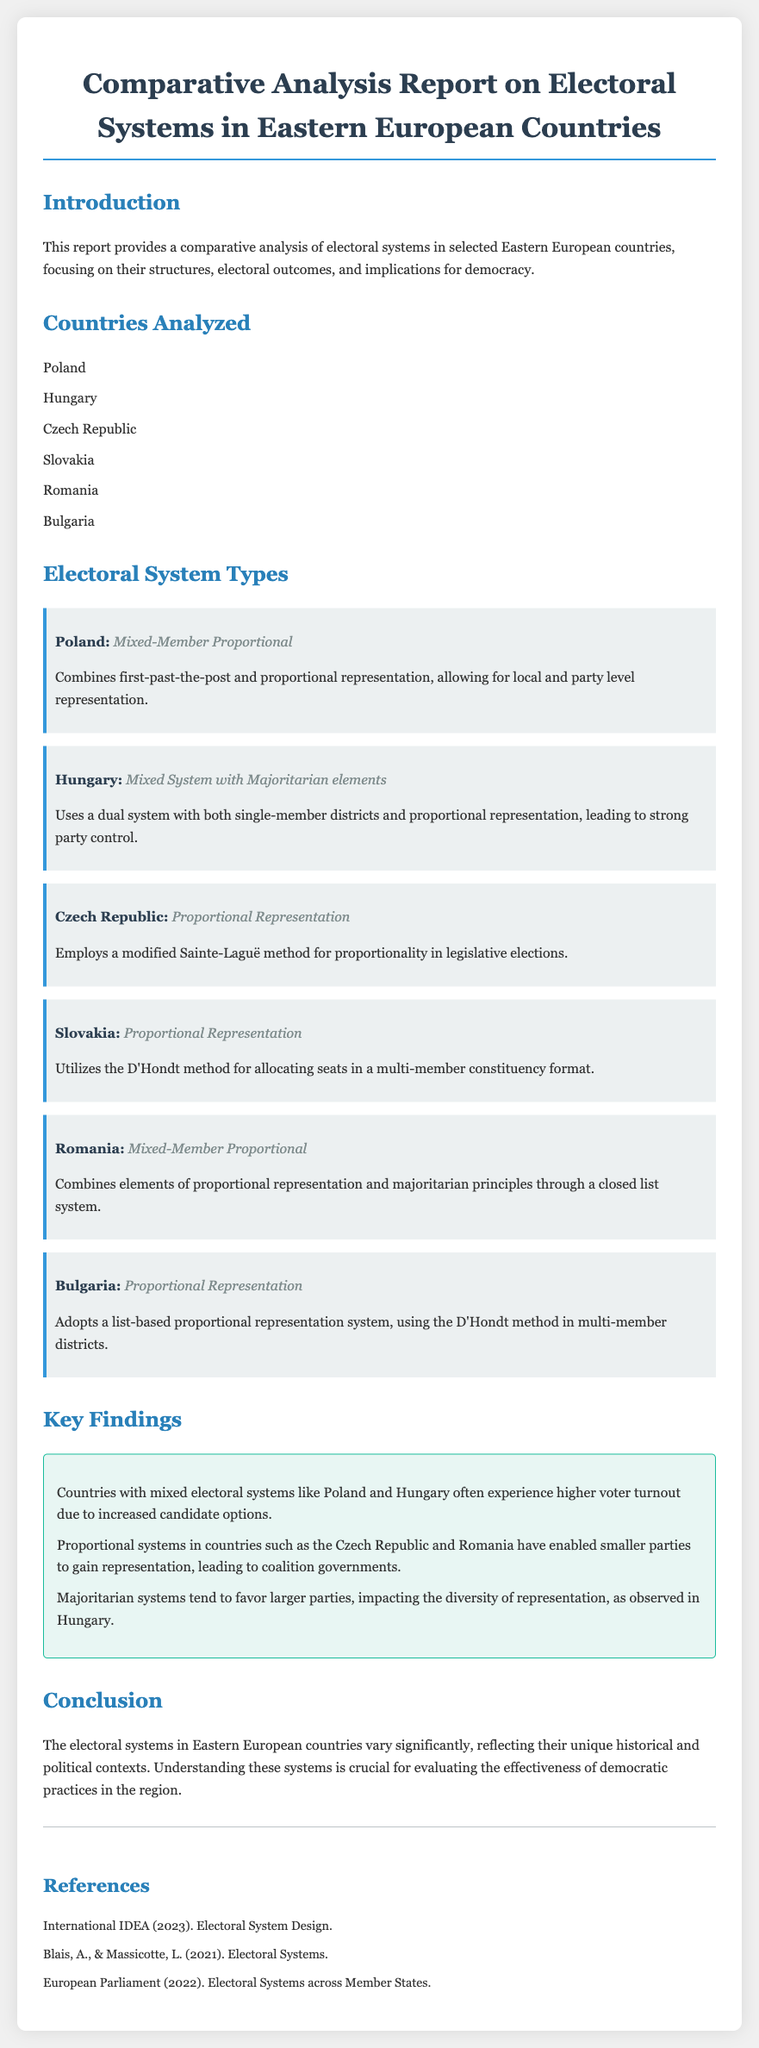What are the countries analyzed? The document lists the countries analyzed in the report under the section "Countries Analyzed."
Answer: Poland, Hungary, Czech Republic, Slovakia, Romania, Bulgaria What electoral system does Poland use? The document specifies the electoral system used in Poland in the "Electoral System Types" section.
Answer: Mixed-Member Proportional What method is used in the Czech Republic for proportional representation? The document describes the method used for proportional representation in the Czech Republic.
Answer: Modified Sainte-Laguë method Which country has a mixed system with majoritarian elements? The report identifies the country with this specific electoral system type in the "Electoral System Types" section.
Answer: Hungary What is one key finding related to mixed electoral systems? The document provides key findings about mixed electoral systems under the "Key Findings" section.
Answer: Higher voter turnout due to increased candidate options Which electoral system is used in Bulgaria? The document notes the type of electoral system Bulgaria employs in the "Electoral System Types" section.
Answer: Proportional Representation What kind of representation do smaller parties gain in proportional systems? The document mentions the impact of proportional systems on smaller parties in the "Key Findings" section.
Answer: Representation How many key findings are listed in the "Key Findings" section? The report provides multiple key findings, which can be counted in the relevant section.
Answer: Three 